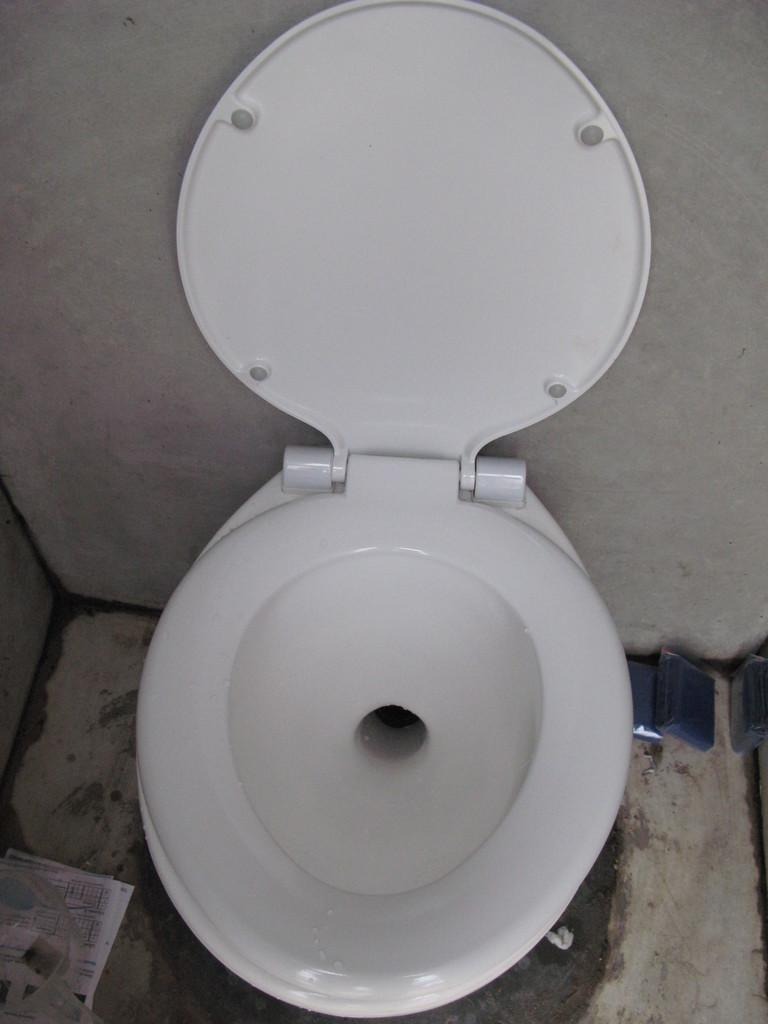What is the main object in the image? There is a toilet in the image. What is located behind the toilet? There is a wall in the image. What is on the floor in the image? There are papers on the floor in the image. What type of garden can be seen through the window in the image? There is no window or garden present in the image; it only features a toilet and a wall. 